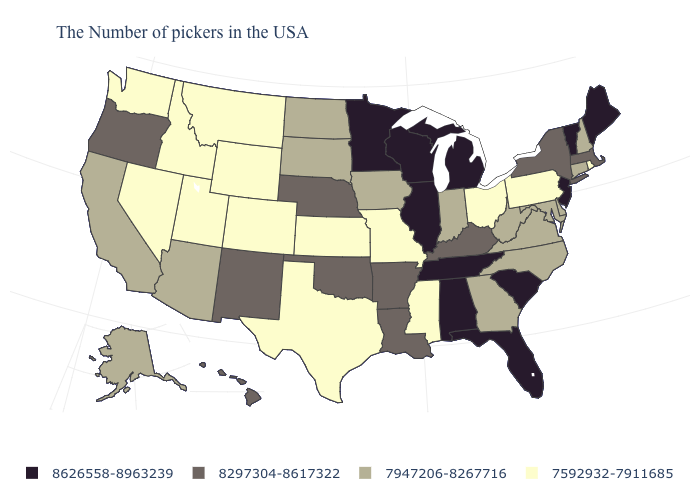Does Colorado have the lowest value in the West?
Give a very brief answer. Yes. Name the states that have a value in the range 7592932-7911685?
Concise answer only. Rhode Island, Pennsylvania, Ohio, Mississippi, Missouri, Kansas, Texas, Wyoming, Colorado, Utah, Montana, Idaho, Nevada, Washington. What is the value of Colorado?
Quick response, please. 7592932-7911685. Does New Mexico have the lowest value in the West?
Write a very short answer. No. Name the states that have a value in the range 7947206-8267716?
Short answer required. New Hampshire, Connecticut, Delaware, Maryland, Virginia, North Carolina, West Virginia, Georgia, Indiana, Iowa, South Dakota, North Dakota, Arizona, California, Alaska. What is the value of Arizona?
Concise answer only. 7947206-8267716. Does the map have missing data?
Answer briefly. No. What is the value of Indiana?
Be succinct. 7947206-8267716. Does Illinois have the lowest value in the USA?
Answer briefly. No. What is the highest value in states that border Maryland?
Keep it brief. 7947206-8267716. Does Alaska have the lowest value in the USA?
Keep it brief. No. Among the states that border Massachusetts , which have the lowest value?
Quick response, please. Rhode Island. Which states have the highest value in the USA?
Quick response, please. Maine, Vermont, New Jersey, South Carolina, Florida, Michigan, Alabama, Tennessee, Wisconsin, Illinois, Minnesota. Does the first symbol in the legend represent the smallest category?
Short answer required. No. Does the map have missing data?
Concise answer only. No. 